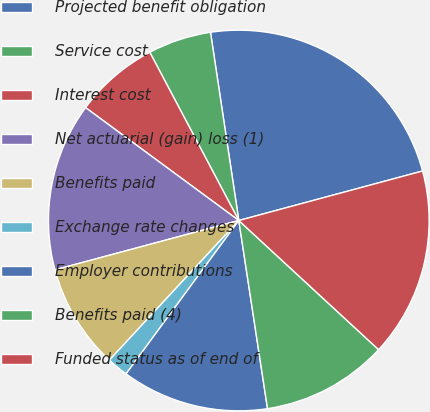<chart> <loc_0><loc_0><loc_500><loc_500><pie_chart><fcel>Projected benefit obligation<fcel>Service cost<fcel>Interest cost<fcel>Net actuarial (gain) loss (1)<fcel>Benefits paid<fcel>Exchange rate changes<fcel>Employer contributions<fcel>Benefits paid (4)<fcel>Funded status as of end of<nl><fcel>23.19%<fcel>5.37%<fcel>7.15%<fcel>14.28%<fcel>8.93%<fcel>1.81%<fcel>12.5%<fcel>10.72%<fcel>16.06%<nl></chart> 